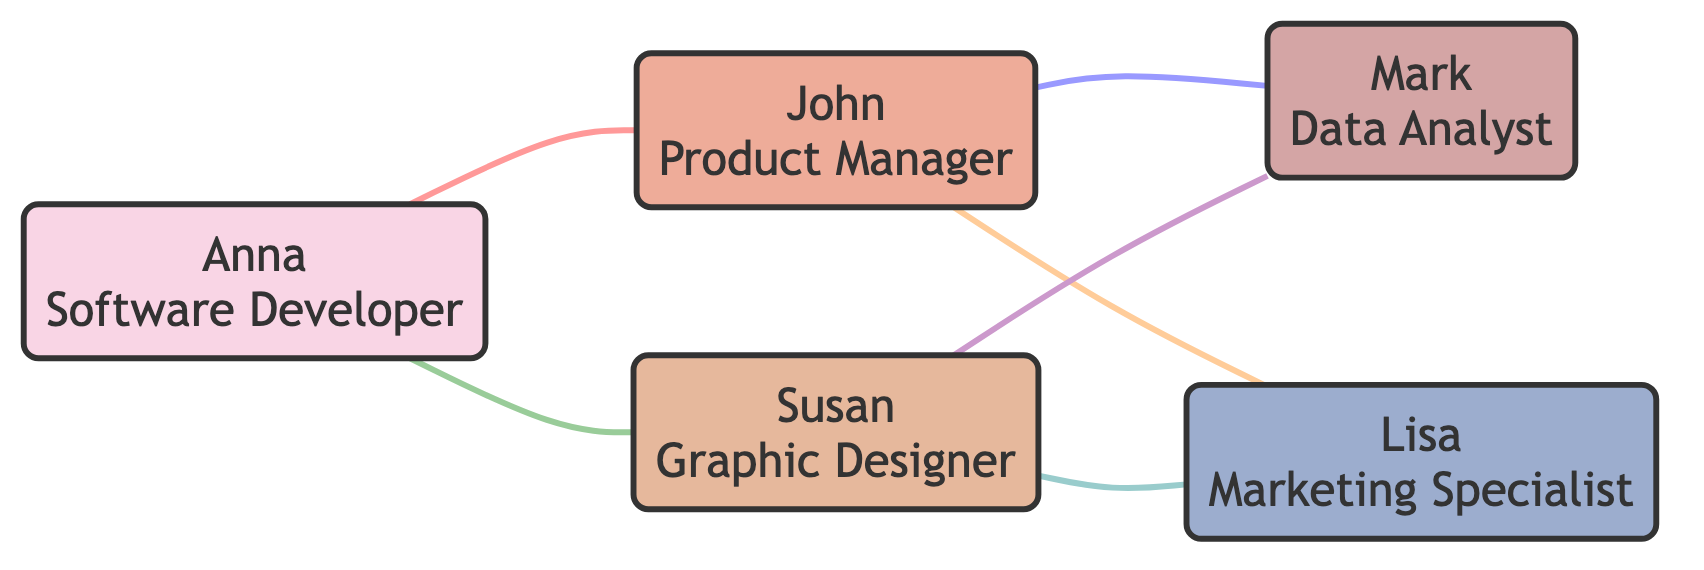What is the total number of nodes in the graph? By counting the nodes listed in the diagram data, we see that there are five unique individuals: Anna, John, Susan, Mark, and Lisa.
Answer: 5 Which role does Anna have? Looking at the node information, Anna is identified as a Software Developer.
Answer: Software Developer How many interactions does John have in total? Examining the edges that include John, we find he is involved in three interactions: with Anna, Mark, and Lisa.
Answer: 3 What type of interaction exists between Susan and Mark? The edge connecting Susan and Mark is labeled as "Design Analysis," representing the nature of their interaction.
Answer: Design Analysis Which person does Lisa collaborate with on marketing strategy discussions? Referring to the edges in the diagram, Lisa is connected to John, indicating their collaboration involves "Marketing Strategy Discussion."
Answer: John What is the relationship between Anna and Susan? The edge drawn between Anna and Susan represents their "Project Collaboration."
Answer: Project Collaboration Which two nodes have the most interactions? Analyzing the interactions, John is connected to three nodes, and Susan is connected to three nodes as well, making them equally active in interactions.
Answer: John and Susan What role is connected to the interaction labeled "Branding Projects"? The interaction labeled "Branding Projects" connects Susan and Lisa, as shown in the edges.
Answer: Graphic Designer Which pair of individuals interacts on "Data Review"? From the edges in the diagram, the interaction "Data Review" exists between John and Mark.
Answer: John and Mark 